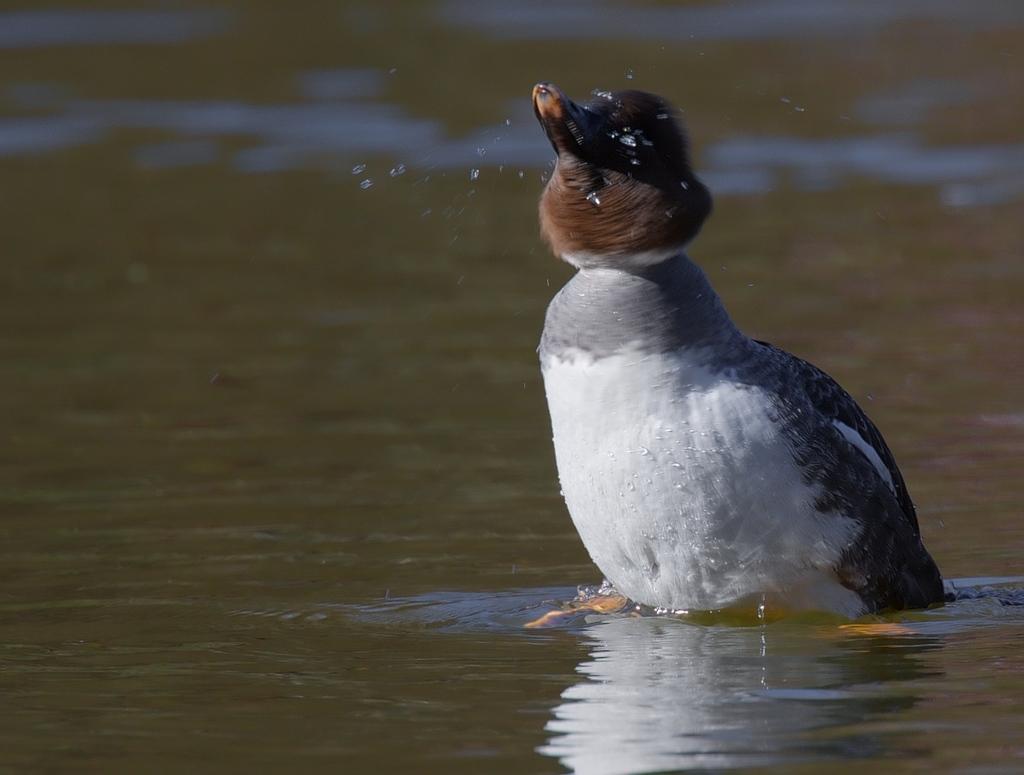Can you describe this image briefly? In the center of the image there is a bird. At the bottom there is water. 